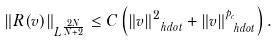Convert formula to latex. <formula><loc_0><loc_0><loc_500><loc_500>\| R ( v ) \| _ { L ^ { \frac { 2 N } { N + 2 } } } \leq C \left ( \| v \| ^ { 2 } _ { \ h d o t } + \| v \| _ { \ h d o t } ^ { p _ { c } } \right ) .</formula> 